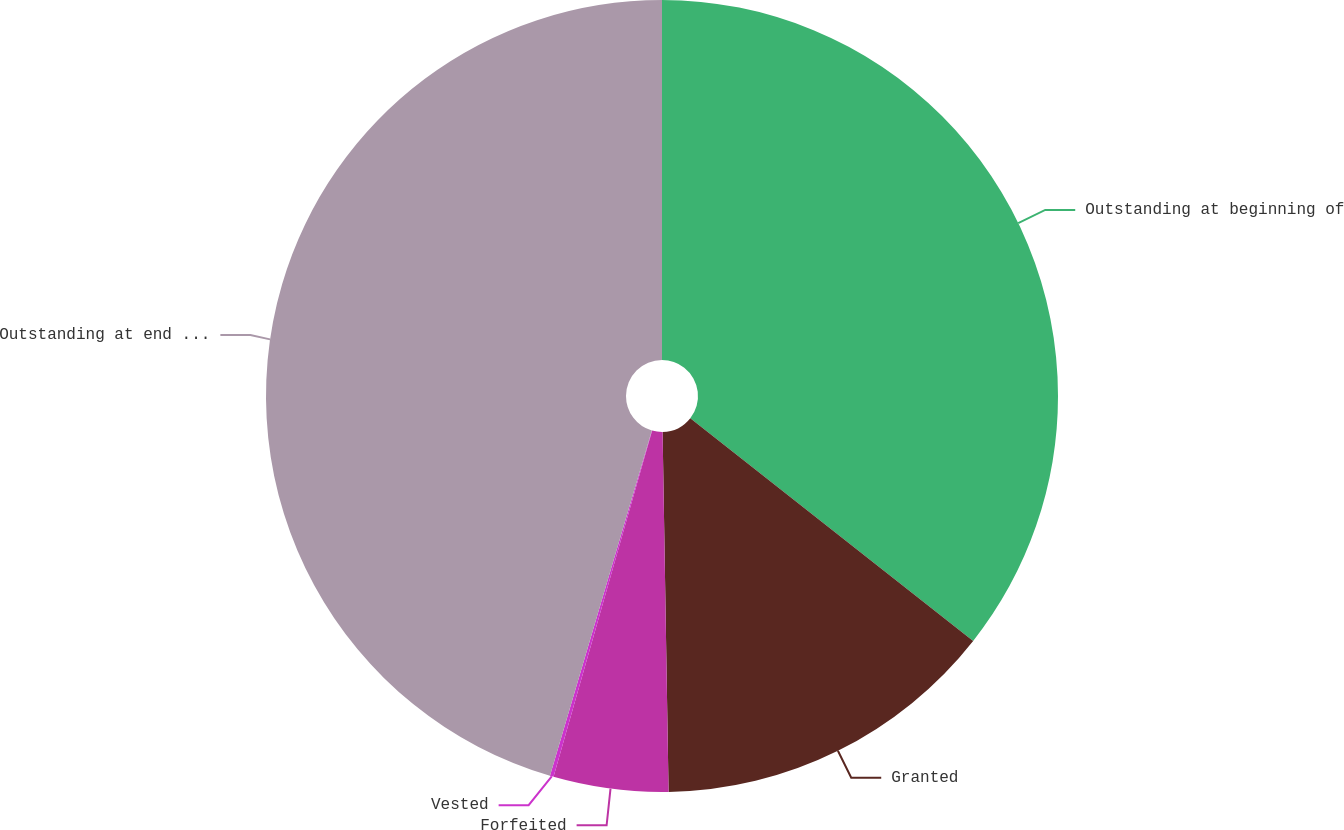Convert chart. <chart><loc_0><loc_0><loc_500><loc_500><pie_chart><fcel>Outstanding at beginning of<fcel>Granted<fcel>Forfeited<fcel>Vested<fcel>Outstanding at end of year<nl><fcel>35.61%<fcel>14.12%<fcel>4.68%<fcel>0.15%<fcel>45.43%<nl></chart> 